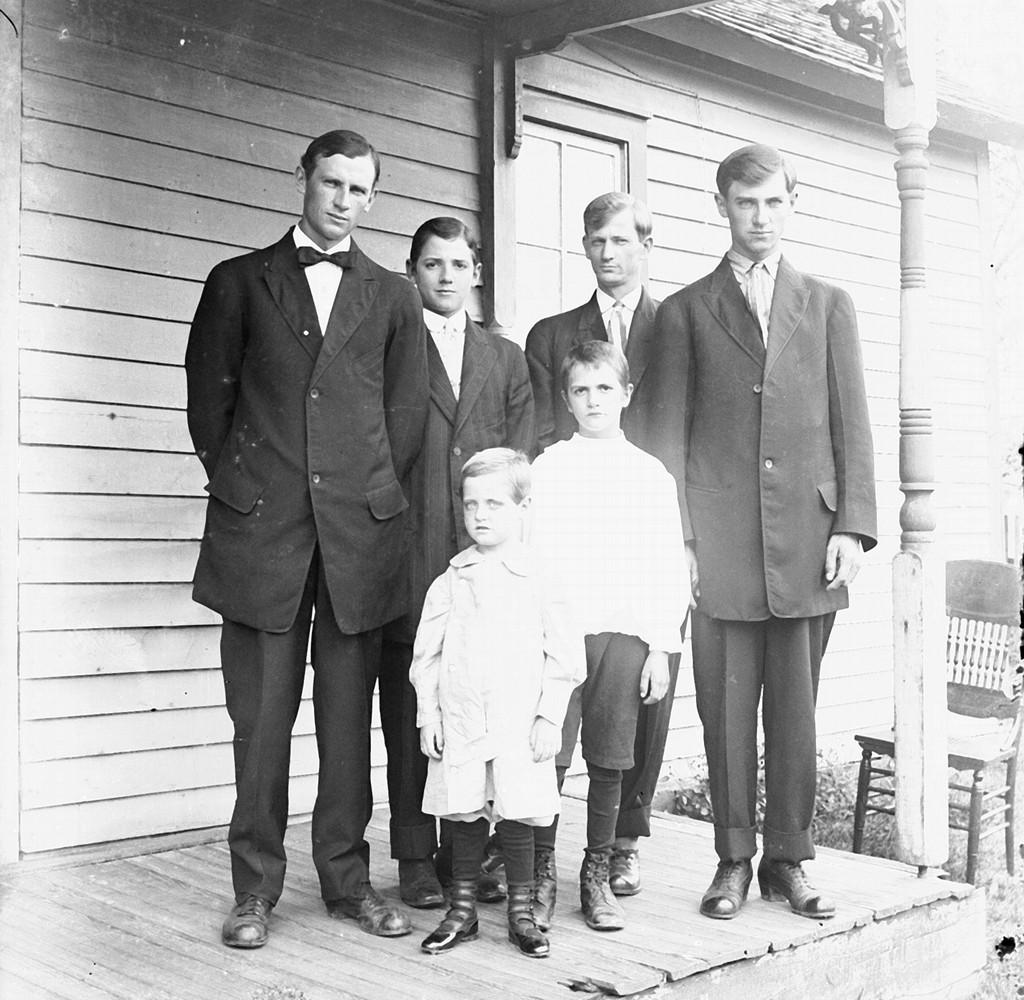What is the color scheme of the image? The image is black and white. How many men are present in the image? There are four men standing in the image. What are the men wearing? The men are wearing black coats and black trousers. Are there any children in the image? Yes, there are two children standing in the image. What type of amusement can be seen in the image? There is no amusement present in the image; it features four men and two children wearing black coats and trousers. What color is the hair of the children in the image? The image is black and white, so it is not possible to determine the color of the children's hair. 